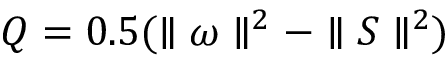<formula> <loc_0><loc_0><loc_500><loc_500>Q = 0 . 5 ( \| \omega \| ^ { 2 } - \| S \| ^ { 2 } )</formula> 